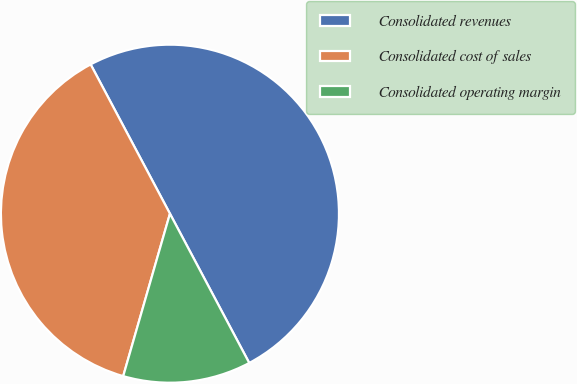Convert chart to OTSL. <chart><loc_0><loc_0><loc_500><loc_500><pie_chart><fcel>Consolidated revenues<fcel>Consolidated cost of sales<fcel>Consolidated operating margin<nl><fcel>50.0%<fcel>37.77%<fcel>12.23%<nl></chart> 